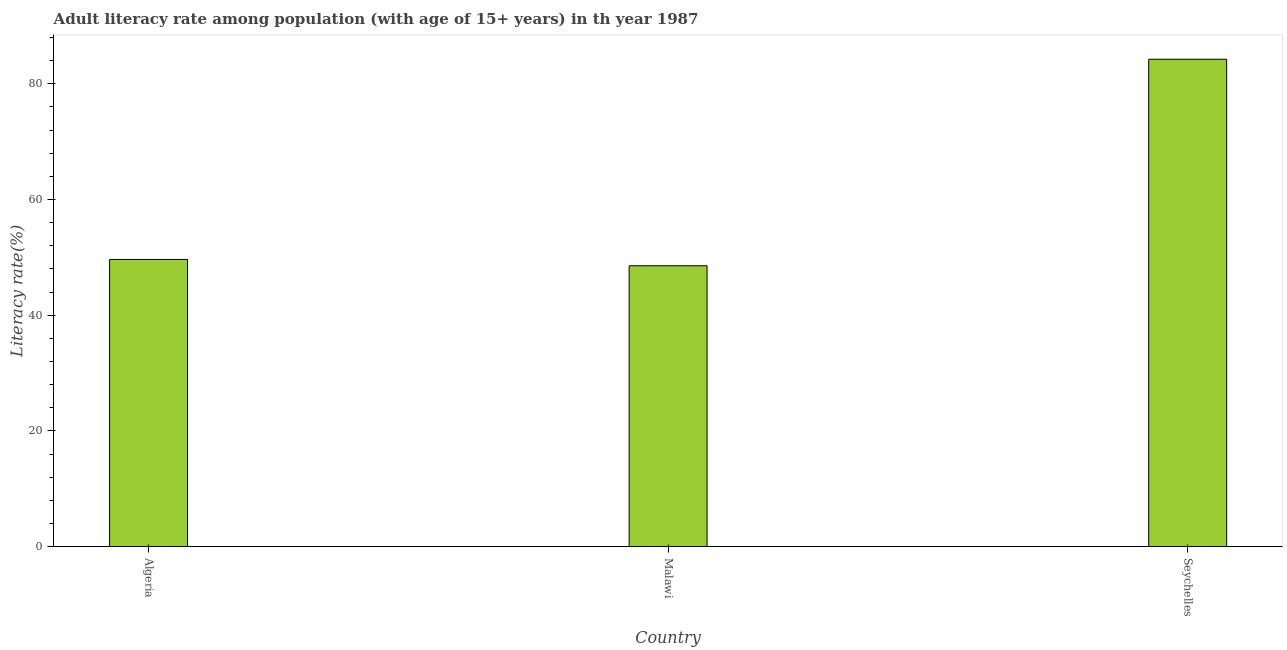Does the graph contain grids?
Ensure brevity in your answer.  No. What is the title of the graph?
Provide a short and direct response. Adult literacy rate among population (with age of 15+ years) in th year 1987. What is the label or title of the Y-axis?
Offer a terse response. Literacy rate(%). What is the adult literacy rate in Algeria?
Provide a succinct answer. 49.63. Across all countries, what is the maximum adult literacy rate?
Give a very brief answer. 84.23. Across all countries, what is the minimum adult literacy rate?
Your answer should be compact. 48.54. In which country was the adult literacy rate maximum?
Provide a succinct answer. Seychelles. In which country was the adult literacy rate minimum?
Make the answer very short. Malawi. What is the sum of the adult literacy rate?
Your answer should be very brief. 182.4. What is the difference between the adult literacy rate in Algeria and Seychelles?
Your answer should be compact. -34.6. What is the average adult literacy rate per country?
Provide a short and direct response. 60.8. What is the median adult literacy rate?
Keep it short and to the point. 49.63. In how many countries, is the adult literacy rate greater than 44 %?
Offer a very short reply. 3. What is the ratio of the adult literacy rate in Algeria to that in Seychelles?
Your answer should be very brief. 0.59. Is the adult literacy rate in Algeria less than that in Seychelles?
Your response must be concise. Yes. What is the difference between the highest and the second highest adult literacy rate?
Your answer should be compact. 34.6. What is the difference between the highest and the lowest adult literacy rate?
Your answer should be compact. 35.69. In how many countries, is the adult literacy rate greater than the average adult literacy rate taken over all countries?
Keep it short and to the point. 1. How many bars are there?
Offer a very short reply. 3. Are all the bars in the graph horizontal?
Give a very brief answer. No. What is the difference between two consecutive major ticks on the Y-axis?
Your response must be concise. 20. What is the Literacy rate(%) of Algeria?
Your answer should be compact. 49.63. What is the Literacy rate(%) of Malawi?
Provide a succinct answer. 48.54. What is the Literacy rate(%) in Seychelles?
Keep it short and to the point. 84.23. What is the difference between the Literacy rate(%) in Algeria and Malawi?
Provide a short and direct response. 1.09. What is the difference between the Literacy rate(%) in Algeria and Seychelles?
Your answer should be very brief. -34.6. What is the difference between the Literacy rate(%) in Malawi and Seychelles?
Keep it short and to the point. -35.69. What is the ratio of the Literacy rate(%) in Algeria to that in Malawi?
Make the answer very short. 1.02. What is the ratio of the Literacy rate(%) in Algeria to that in Seychelles?
Make the answer very short. 0.59. What is the ratio of the Literacy rate(%) in Malawi to that in Seychelles?
Give a very brief answer. 0.58. 